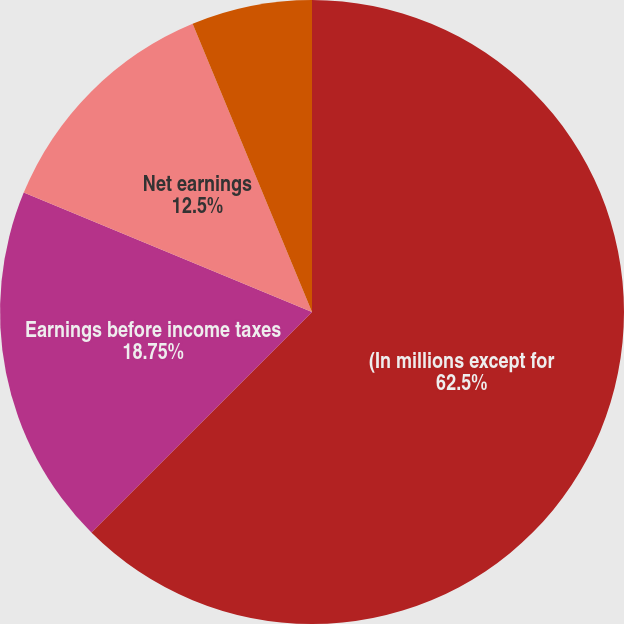<chart> <loc_0><loc_0><loc_500><loc_500><pie_chart><fcel>(In millions except for<fcel>Earnings before income taxes<fcel>Net earnings<fcel>Basic<fcel>Diluted<nl><fcel>62.5%<fcel>18.75%<fcel>12.5%<fcel>0.0%<fcel>6.25%<nl></chart> 